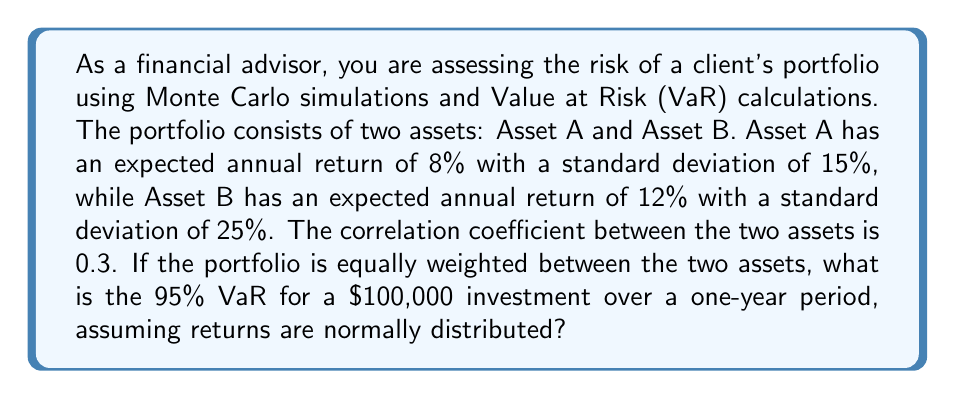Could you help me with this problem? To solve this problem, we'll follow these steps:

1. Calculate the portfolio's expected return:
   $$E(R_p) = w_A \cdot E(R_A) + w_B \cdot E(R_B)$$
   $$E(R_p) = 0.5 \cdot 0.08 + 0.5 \cdot 0.12 = 0.10 = 10\%$$

2. Calculate the portfolio's standard deviation:
   $$\sigma_p = \sqrt{w_A^2\sigma_A^2 + w_B^2\sigma_B^2 + 2w_Aw_B\sigma_A\sigma_B\rho_{AB}}$$
   $$\sigma_p = \sqrt{0.5^2 \cdot 0.15^2 + 0.5^2 \cdot 0.25^2 + 2 \cdot 0.5 \cdot 0.5 \cdot 0.15 \cdot 0.25 \cdot 0.3}$$
   $$\sigma_p = \sqrt{0.0056250 + 0.0156250 + 0.0028125} = \sqrt{0.0240625} = 0.1551 = 15.51\%$$

3. For a 95% VaR, we need the 5th percentile of the normal distribution, which corresponds to approximately -1.645 standard deviations from the mean.

4. Calculate the VaR:
   $$VaR = -(\mu - 1.645\sigma) \cdot Investment$$
   where $\mu$ is the expected return and $\sigma$ is the standard deviation.

   $$VaR = -(0.10 - 1.645 \cdot 0.1551) \cdot 100,000$$
   $$VaR = -(0.10 - 0.2551) \cdot 100,000$$
   $$VaR = 0.1551 \cdot 100,000 = 15,510$$

Therefore, the 95% VaR for a $100,000 investment over a one-year period is $15,510.
Answer: $15,510 